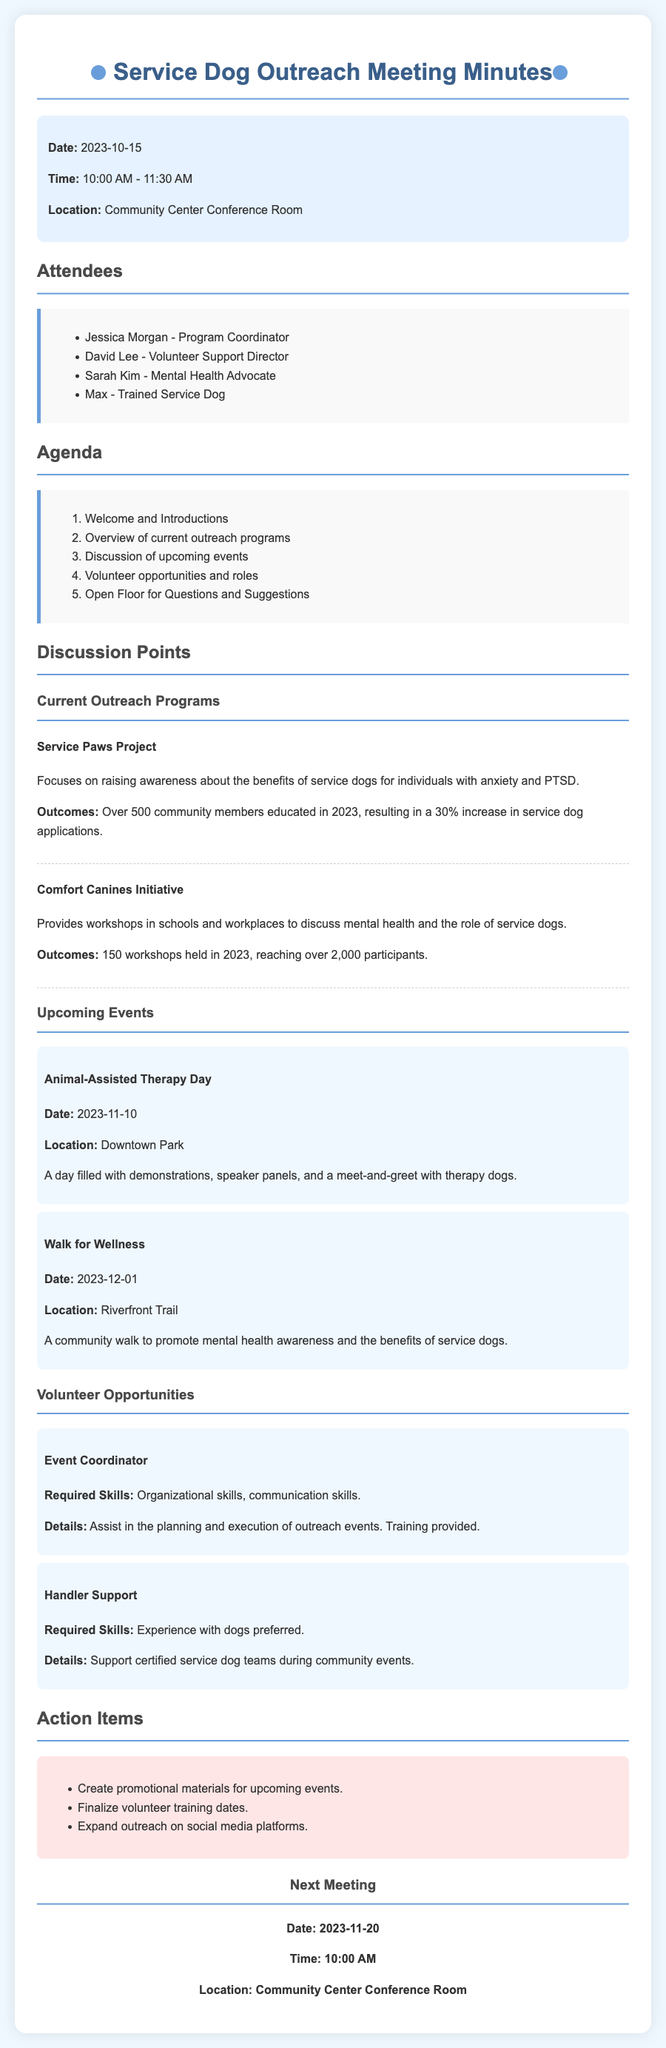What date was the meeting held? The date of the meeting is clearly stated in the header information.
Answer: 2023-10-15 Who is the Program Coordinator? The attendees section lists Jessica Morgan as the Program Coordinator.
Answer: Jessica Morgan What is the location of the next meeting? The next meeting location is mentioned in the next meeting section.
Answer: Community Center Conference Room How many participants were reached by the Comfort Canines Initiative in 2023? The outcomes of the Comfort Canines Initiative specify the number of participants reached.
Answer: over 2,000 What is one role available for volunteers? The volunteer opportunities section lists various roles, including Event Coordinator.
Answer: Event Coordinator How many workshops were held by the Comfort Canines Initiative in 2023? This number is directly related to the outcomes provided in the discussion point.
Answer: 150 What event is scheduled for November 10, 2023? The upcoming events section specifies the event taking place on this date.
Answer: Animal-Assisted Therapy Day What percentage increase in service dog applications was reported for 2023? The outcomes state the percentage increase in service dog applications from community outreach.
Answer: 30% 